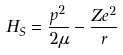Convert formula to latex. <formula><loc_0><loc_0><loc_500><loc_500>H _ { S } = \frac { { p } ^ { 2 } } { 2 \mu } - \frac { Z e ^ { 2 } } { r }</formula> 